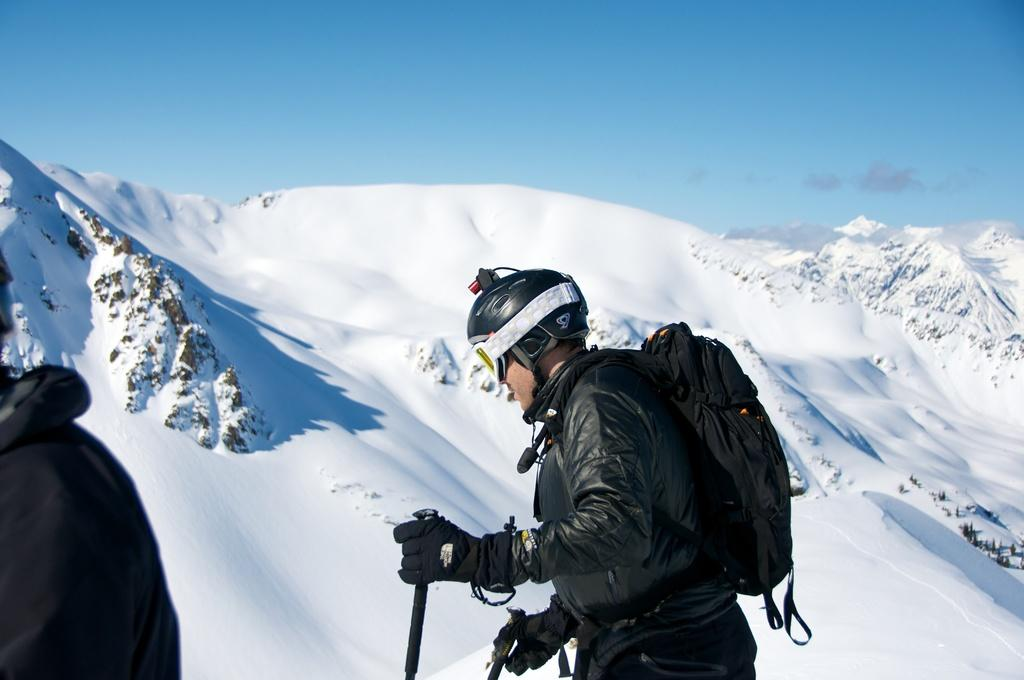What is the main subject of the image? There is a person in the image. What protective gear is the person wearing? The person is wearing gloves and a helmet. What is the person carrying? The person is carrying a bag. What is the person holding? The person is holding sticks. What type of weather is depicted in the image? There is snow visible in the image. What part of the natural environment is visible in the image? The sky is visible in the image. What type of button can be seen on the person's ear in the image? There is no button visible on the person's ear in the image. What adjustment is the person making to their helmet in the image? There is no adjustment being made to the helmet in the image. 